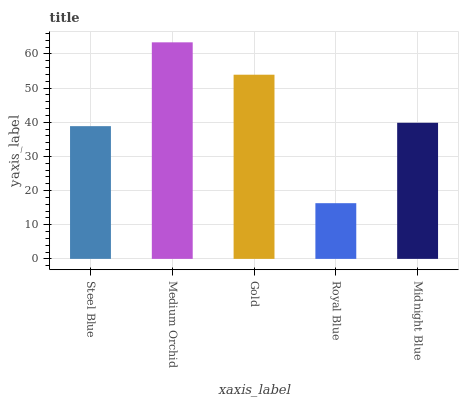Is Royal Blue the minimum?
Answer yes or no. Yes. Is Medium Orchid the maximum?
Answer yes or no. Yes. Is Gold the minimum?
Answer yes or no. No. Is Gold the maximum?
Answer yes or no. No. Is Medium Orchid greater than Gold?
Answer yes or no. Yes. Is Gold less than Medium Orchid?
Answer yes or no. Yes. Is Gold greater than Medium Orchid?
Answer yes or no. No. Is Medium Orchid less than Gold?
Answer yes or no. No. Is Midnight Blue the high median?
Answer yes or no. Yes. Is Midnight Blue the low median?
Answer yes or no. Yes. Is Medium Orchid the high median?
Answer yes or no. No. Is Steel Blue the low median?
Answer yes or no. No. 